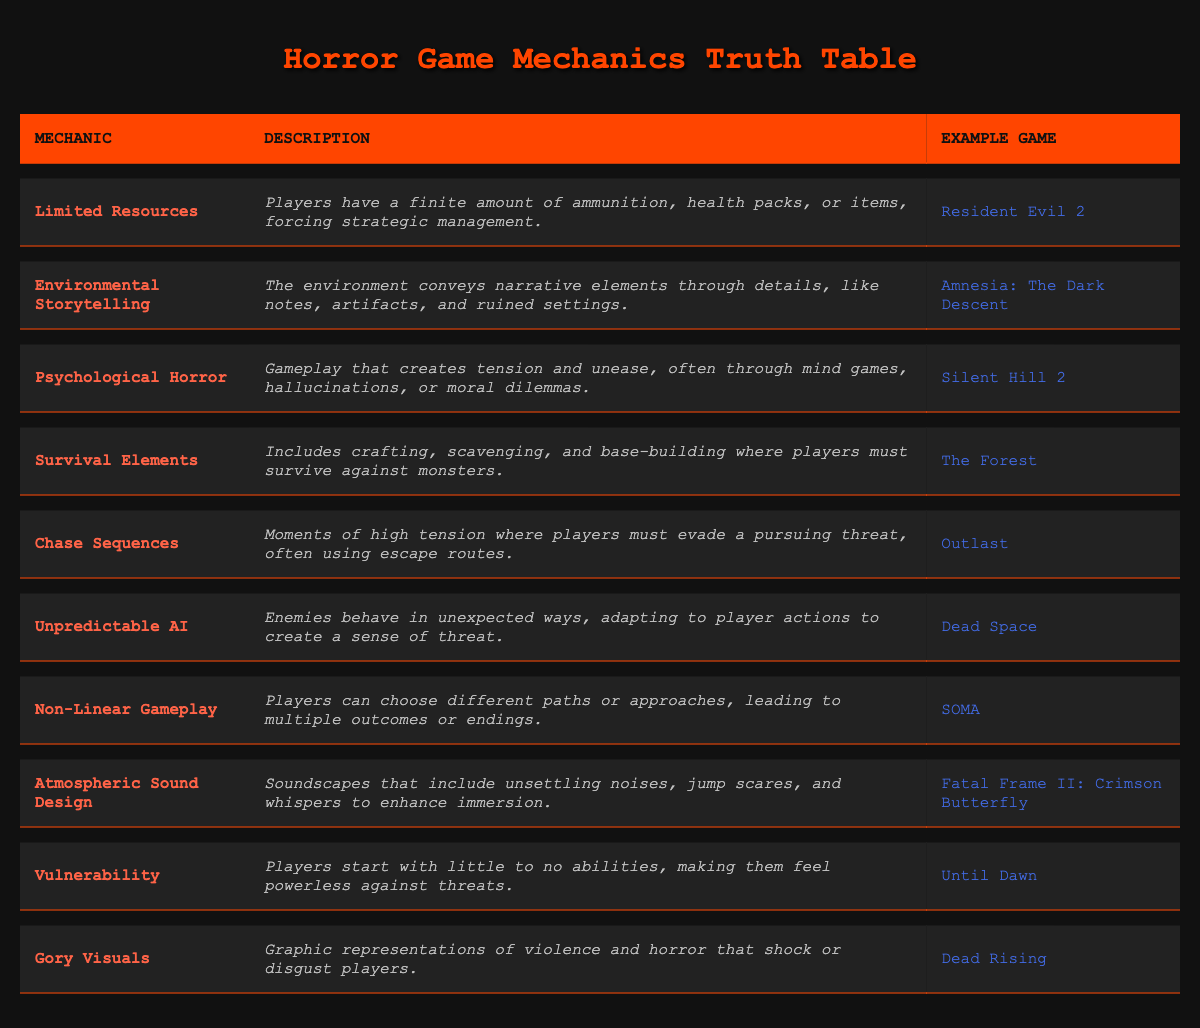What is the mechanic used in "Resident Evil 2"? The table lists "Resident Evil 2" under the example game column for the mechanic "Limited Resources".
Answer: Limited Resources Which game is known for "Environmental Storytelling"? The table specifies that "Amnesia: The Dark Descent" is an example game for the mechanic "Environmental Storytelling".
Answer: Amnesia: The Dark Descent Does "Dead Space" feature Unpredictable AI? According to the table, "Dead Space" is mentioned as the example game for the mechanic "Unpredictable AI". Thus, it can be confirmed that it features this mechanic.
Answer: Yes What are at least two game mechanics used in horror games? By checking the mechanic column in the table, we find several options. For instance, "Psychological Horror" and "Gory Visuals" are both valid examples.
Answer: Psychological Horror, Gory Visuals How many mechanics listed involve player vulnerability? The table lists just one mechanic specifically focused on player vulnerability, which is "Vulnerability" with the example game "Until Dawn".
Answer: 1 Which mechanic has a focus on auditory elements? The table identifies "Atmospheric Sound Design" as the mechanic that emphasizes auditory experiences in horror games.
Answer: Atmospheric Sound Design Which example game utilizes a mechanic involving crafting and scavenging? The mechanic "Survival Elements" in the table is linked to the example game "The Forest", indicating it involves crafting and scavenging.
Answer: The Forest Are there more mechanics focused on player resources or psychological elements? The table displays four mechanics related to player resources (Limited Resources, Survival Elements) and three related to psychological elements (Psychological Horror, Chase Sequences). Therefore, resources are more emphasized.
Answer: Player resources List the mechanics that promote a non-linear gameplay experience. The table clearly states that "Non-Linear Gameplay" is the only mechanic that directly promotes this type of gameplay. The example game associated with it is "SOMA".
Answer: Non-Linear Gameplay 